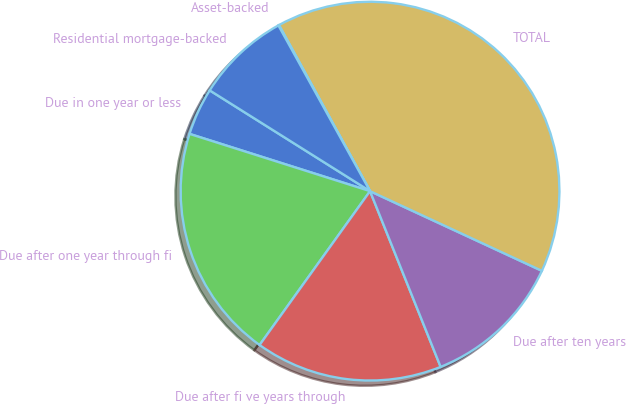<chart> <loc_0><loc_0><loc_500><loc_500><pie_chart><fcel>Due in one year or less<fcel>Due after one year through fi<fcel>Due after fi ve years through<fcel>Due after ten years<fcel>TOTAL<fcel>Asset-backed<fcel>Residential mortgage-backed<nl><fcel>4.04%<fcel>19.98%<fcel>15.99%<fcel>12.01%<fcel>39.89%<fcel>0.06%<fcel>8.03%<nl></chart> 